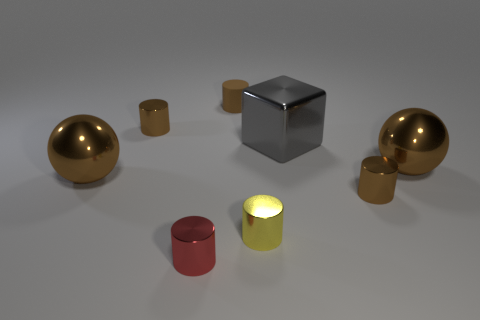Are there any indications about the function of these objects or is this purely an aesthetic arrangement? Based on the image, it seems to be an aesthetic arrangement designed to showcase the interplay of shapes and reflections. There are no clear indications that these objects serve a particular function, suggesting that the primary focus is on visual appeal and the study of form. 